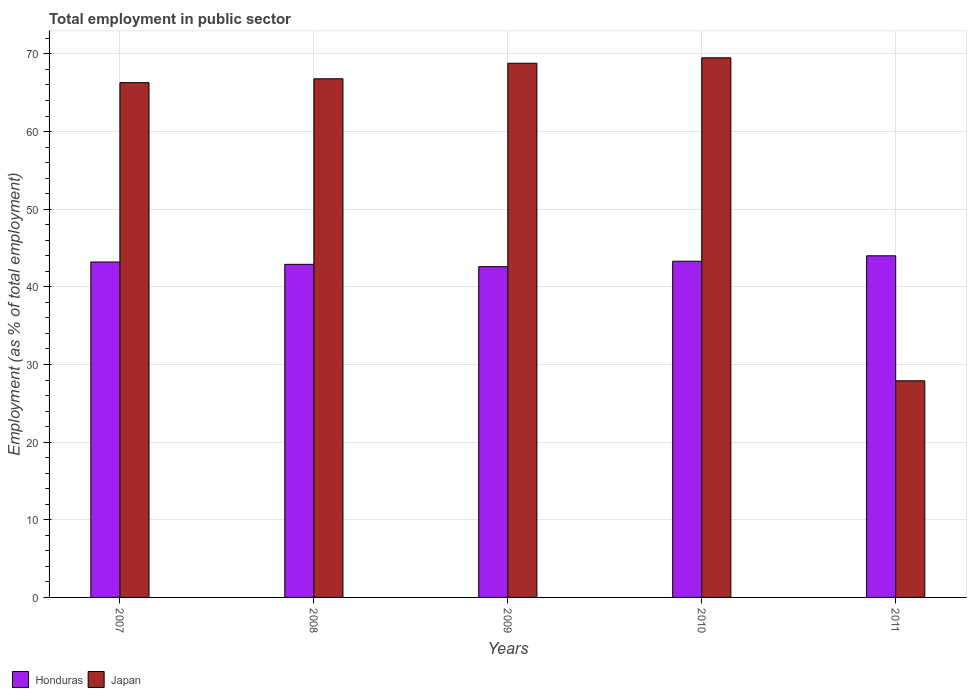Are the number of bars per tick equal to the number of legend labels?
Offer a very short reply. Yes. How many bars are there on the 3rd tick from the left?
Your answer should be very brief. 2. How many bars are there on the 5th tick from the right?
Your answer should be very brief. 2. Across all years, what is the maximum employment in public sector in Japan?
Your answer should be compact. 69.5. Across all years, what is the minimum employment in public sector in Honduras?
Ensure brevity in your answer.  42.6. In which year was the employment in public sector in Honduras maximum?
Offer a very short reply. 2011. What is the total employment in public sector in Japan in the graph?
Keep it short and to the point. 299.3. What is the difference between the employment in public sector in Japan in 2010 and that in 2011?
Your answer should be compact. 41.6. What is the difference between the employment in public sector in Japan in 2008 and the employment in public sector in Honduras in 2010?
Your answer should be compact. 23.5. What is the average employment in public sector in Japan per year?
Your answer should be compact. 59.86. In the year 2011, what is the difference between the employment in public sector in Japan and employment in public sector in Honduras?
Make the answer very short. -16.1. What is the ratio of the employment in public sector in Japan in 2007 to that in 2009?
Your response must be concise. 0.96. Is the employment in public sector in Japan in 2008 less than that in 2009?
Provide a short and direct response. Yes. What is the difference between the highest and the second highest employment in public sector in Honduras?
Make the answer very short. 0.7. What is the difference between the highest and the lowest employment in public sector in Japan?
Your response must be concise. 41.6. What does the 1st bar from the left in 2011 represents?
Ensure brevity in your answer.  Honduras. How many bars are there?
Give a very brief answer. 10. Are all the bars in the graph horizontal?
Provide a short and direct response. No. Where does the legend appear in the graph?
Your answer should be compact. Bottom left. What is the title of the graph?
Your answer should be compact. Total employment in public sector. What is the label or title of the X-axis?
Ensure brevity in your answer.  Years. What is the label or title of the Y-axis?
Give a very brief answer. Employment (as % of total employment). What is the Employment (as % of total employment) of Honduras in 2007?
Provide a short and direct response. 43.2. What is the Employment (as % of total employment) in Japan in 2007?
Provide a short and direct response. 66.3. What is the Employment (as % of total employment) in Honduras in 2008?
Give a very brief answer. 42.9. What is the Employment (as % of total employment) in Japan in 2008?
Your answer should be very brief. 66.8. What is the Employment (as % of total employment) in Honduras in 2009?
Ensure brevity in your answer.  42.6. What is the Employment (as % of total employment) in Japan in 2009?
Offer a very short reply. 68.8. What is the Employment (as % of total employment) of Honduras in 2010?
Keep it short and to the point. 43.3. What is the Employment (as % of total employment) of Japan in 2010?
Ensure brevity in your answer.  69.5. What is the Employment (as % of total employment) in Japan in 2011?
Your answer should be very brief. 27.9. Across all years, what is the maximum Employment (as % of total employment) of Honduras?
Ensure brevity in your answer.  44. Across all years, what is the maximum Employment (as % of total employment) of Japan?
Your answer should be very brief. 69.5. Across all years, what is the minimum Employment (as % of total employment) in Honduras?
Your answer should be compact. 42.6. Across all years, what is the minimum Employment (as % of total employment) of Japan?
Your answer should be very brief. 27.9. What is the total Employment (as % of total employment) of Honduras in the graph?
Ensure brevity in your answer.  216. What is the total Employment (as % of total employment) of Japan in the graph?
Ensure brevity in your answer.  299.3. What is the difference between the Employment (as % of total employment) of Honduras in 2007 and that in 2008?
Keep it short and to the point. 0.3. What is the difference between the Employment (as % of total employment) of Japan in 2007 and that in 2008?
Ensure brevity in your answer.  -0.5. What is the difference between the Employment (as % of total employment) of Honduras in 2007 and that in 2009?
Make the answer very short. 0.6. What is the difference between the Employment (as % of total employment) in Honduras in 2007 and that in 2010?
Ensure brevity in your answer.  -0.1. What is the difference between the Employment (as % of total employment) in Japan in 2007 and that in 2011?
Your answer should be compact. 38.4. What is the difference between the Employment (as % of total employment) in Japan in 2008 and that in 2009?
Provide a succinct answer. -2. What is the difference between the Employment (as % of total employment) in Honduras in 2008 and that in 2010?
Give a very brief answer. -0.4. What is the difference between the Employment (as % of total employment) of Japan in 2008 and that in 2010?
Offer a terse response. -2.7. What is the difference between the Employment (as % of total employment) of Japan in 2008 and that in 2011?
Keep it short and to the point. 38.9. What is the difference between the Employment (as % of total employment) of Japan in 2009 and that in 2011?
Your response must be concise. 40.9. What is the difference between the Employment (as % of total employment) of Honduras in 2010 and that in 2011?
Provide a short and direct response. -0.7. What is the difference between the Employment (as % of total employment) of Japan in 2010 and that in 2011?
Your answer should be very brief. 41.6. What is the difference between the Employment (as % of total employment) in Honduras in 2007 and the Employment (as % of total employment) in Japan in 2008?
Your answer should be compact. -23.6. What is the difference between the Employment (as % of total employment) of Honduras in 2007 and the Employment (as % of total employment) of Japan in 2009?
Keep it short and to the point. -25.6. What is the difference between the Employment (as % of total employment) of Honduras in 2007 and the Employment (as % of total employment) of Japan in 2010?
Provide a succinct answer. -26.3. What is the difference between the Employment (as % of total employment) in Honduras in 2008 and the Employment (as % of total employment) in Japan in 2009?
Give a very brief answer. -25.9. What is the difference between the Employment (as % of total employment) in Honduras in 2008 and the Employment (as % of total employment) in Japan in 2010?
Your answer should be compact. -26.6. What is the difference between the Employment (as % of total employment) in Honduras in 2009 and the Employment (as % of total employment) in Japan in 2010?
Give a very brief answer. -26.9. What is the average Employment (as % of total employment) of Honduras per year?
Ensure brevity in your answer.  43.2. What is the average Employment (as % of total employment) of Japan per year?
Your answer should be compact. 59.86. In the year 2007, what is the difference between the Employment (as % of total employment) in Honduras and Employment (as % of total employment) in Japan?
Your response must be concise. -23.1. In the year 2008, what is the difference between the Employment (as % of total employment) in Honduras and Employment (as % of total employment) in Japan?
Provide a succinct answer. -23.9. In the year 2009, what is the difference between the Employment (as % of total employment) in Honduras and Employment (as % of total employment) in Japan?
Offer a very short reply. -26.2. In the year 2010, what is the difference between the Employment (as % of total employment) in Honduras and Employment (as % of total employment) in Japan?
Give a very brief answer. -26.2. In the year 2011, what is the difference between the Employment (as % of total employment) of Honduras and Employment (as % of total employment) of Japan?
Your answer should be compact. 16.1. What is the ratio of the Employment (as % of total employment) in Honduras in 2007 to that in 2008?
Your response must be concise. 1.01. What is the ratio of the Employment (as % of total employment) in Japan in 2007 to that in 2008?
Provide a short and direct response. 0.99. What is the ratio of the Employment (as % of total employment) in Honduras in 2007 to that in 2009?
Make the answer very short. 1.01. What is the ratio of the Employment (as % of total employment) of Japan in 2007 to that in 2009?
Offer a very short reply. 0.96. What is the ratio of the Employment (as % of total employment) of Japan in 2007 to that in 2010?
Your answer should be very brief. 0.95. What is the ratio of the Employment (as % of total employment) in Honduras in 2007 to that in 2011?
Offer a terse response. 0.98. What is the ratio of the Employment (as % of total employment) in Japan in 2007 to that in 2011?
Keep it short and to the point. 2.38. What is the ratio of the Employment (as % of total employment) in Honduras in 2008 to that in 2009?
Your answer should be very brief. 1.01. What is the ratio of the Employment (as % of total employment) of Japan in 2008 to that in 2009?
Provide a short and direct response. 0.97. What is the ratio of the Employment (as % of total employment) of Honduras in 2008 to that in 2010?
Keep it short and to the point. 0.99. What is the ratio of the Employment (as % of total employment) of Japan in 2008 to that in 2010?
Make the answer very short. 0.96. What is the ratio of the Employment (as % of total employment) in Japan in 2008 to that in 2011?
Offer a very short reply. 2.39. What is the ratio of the Employment (as % of total employment) of Honduras in 2009 to that in 2010?
Make the answer very short. 0.98. What is the ratio of the Employment (as % of total employment) in Honduras in 2009 to that in 2011?
Ensure brevity in your answer.  0.97. What is the ratio of the Employment (as % of total employment) of Japan in 2009 to that in 2011?
Your answer should be compact. 2.47. What is the ratio of the Employment (as % of total employment) in Honduras in 2010 to that in 2011?
Your answer should be very brief. 0.98. What is the ratio of the Employment (as % of total employment) of Japan in 2010 to that in 2011?
Keep it short and to the point. 2.49. What is the difference between the highest and the second highest Employment (as % of total employment) in Honduras?
Offer a terse response. 0.7. What is the difference between the highest and the lowest Employment (as % of total employment) in Japan?
Your response must be concise. 41.6. 